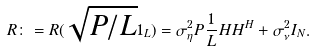Convert formula to latex. <formula><loc_0><loc_0><loc_500><loc_500>R \colon = R ( \sqrt { P / L } 1 _ { L } ) = \sigma _ { \eta } ^ { 2 } P \frac { 1 } { L } H H ^ { H } + \sigma _ { \nu } ^ { 2 } I _ { N } .</formula> 